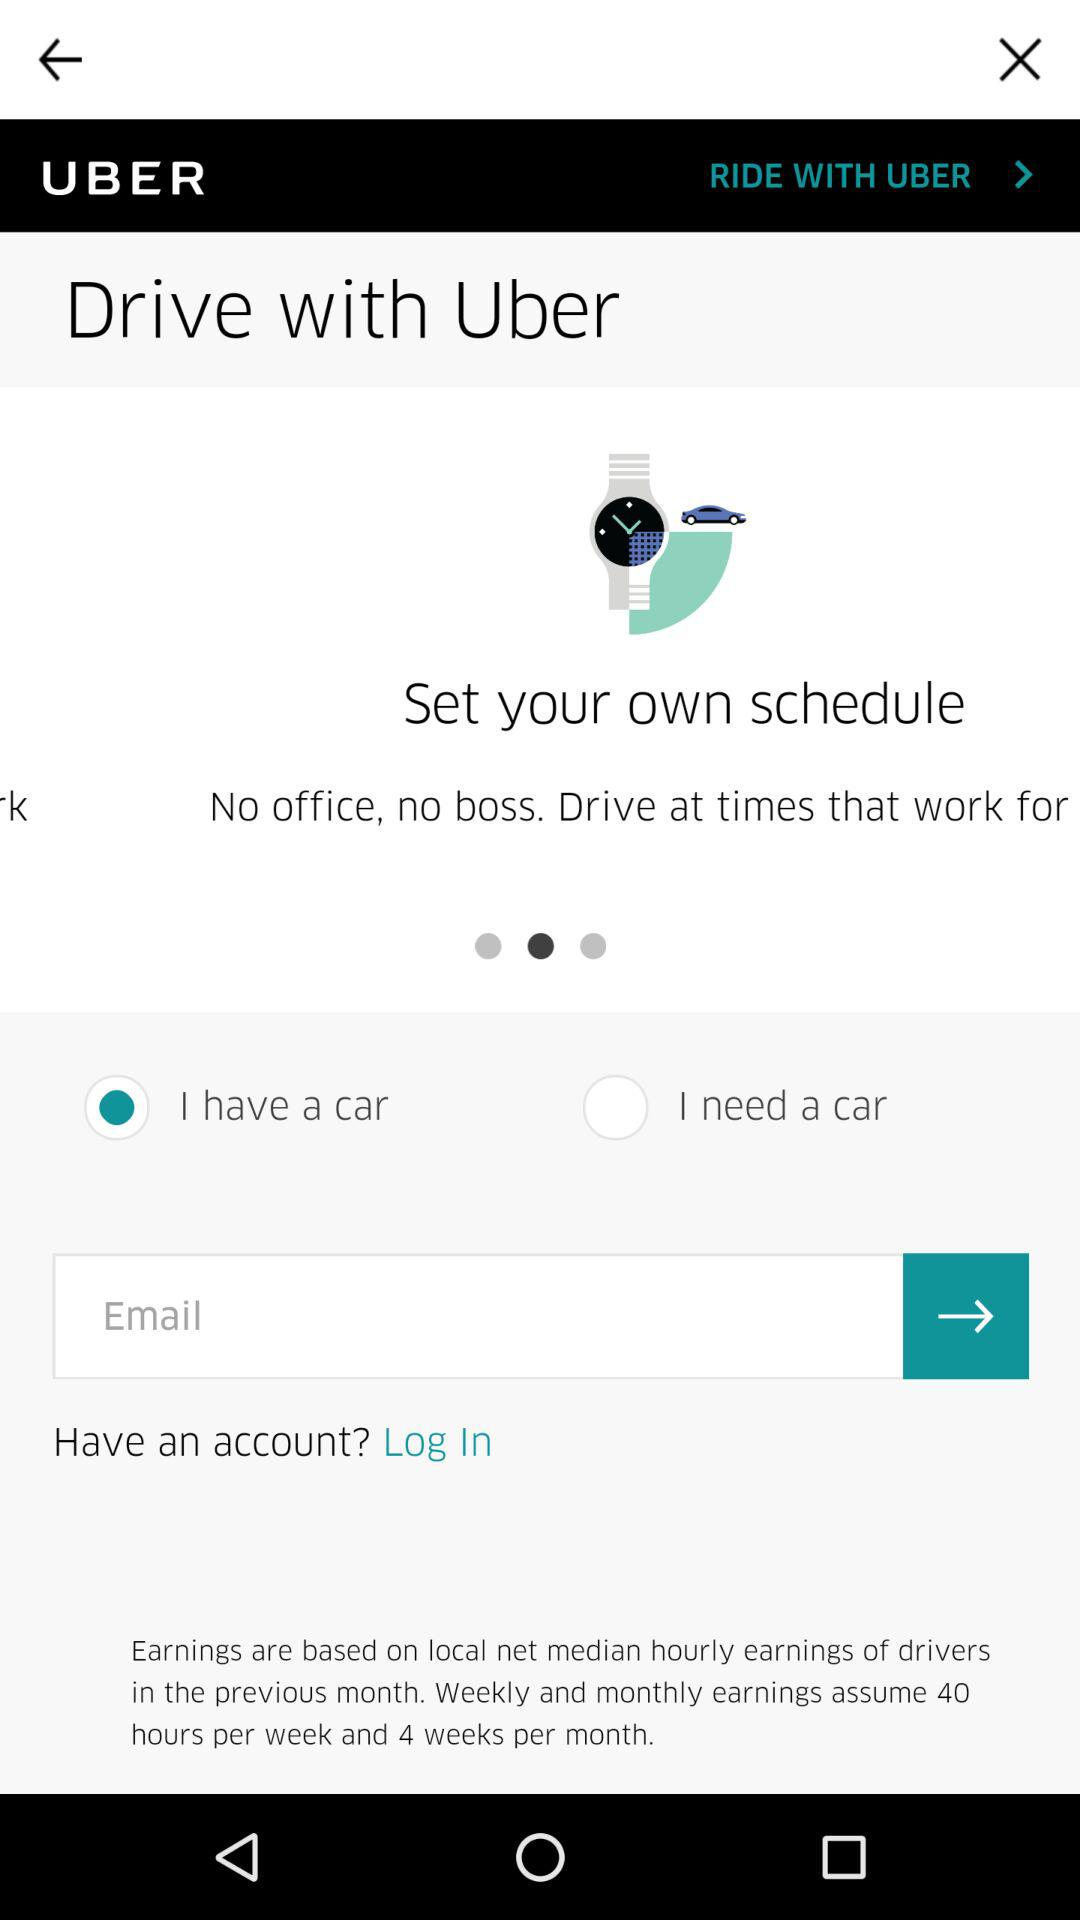What is the application name? The application name is "UBER". 